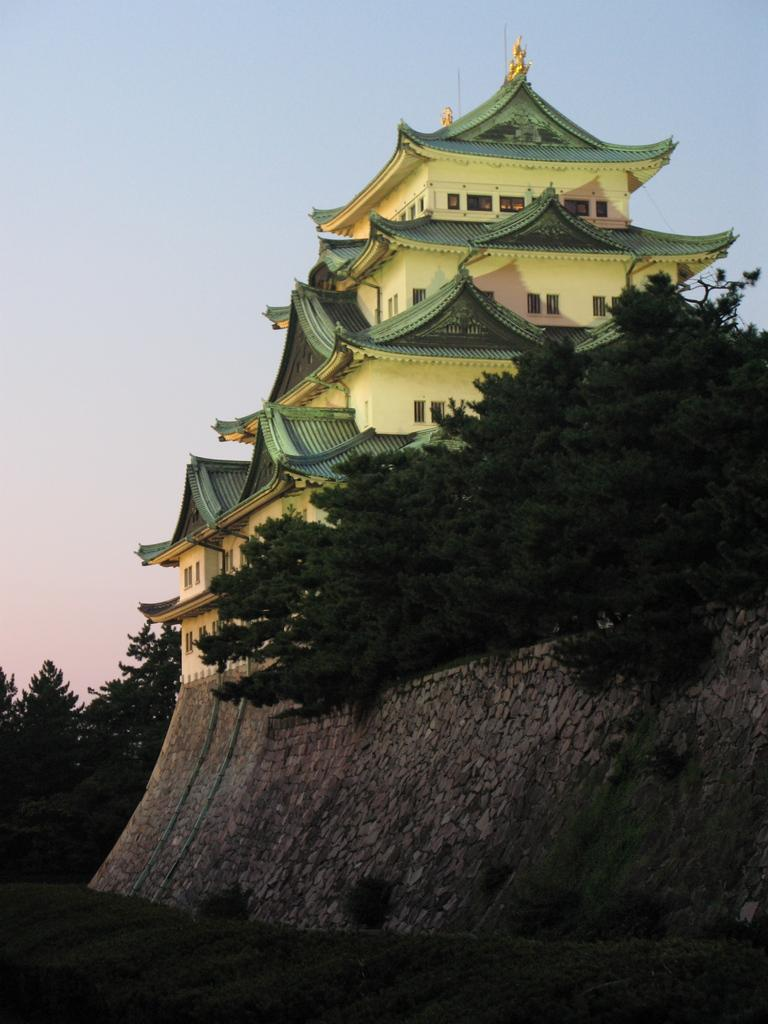What type of structure is in the image? There is a castle in the image. What type of vegetation is present in the image? There are many trees in the image. What part of the natural environment is visible in the image? The grass is visible at the bottom of the image. What is visible at the top of the image? The sky is visible at the top of the image. Where is the school located in the image? There is no school present in the image; it features a castle and natural elements. What type of learning can be observed taking place in the image? There is no learning or educational activity depicted in the image. 